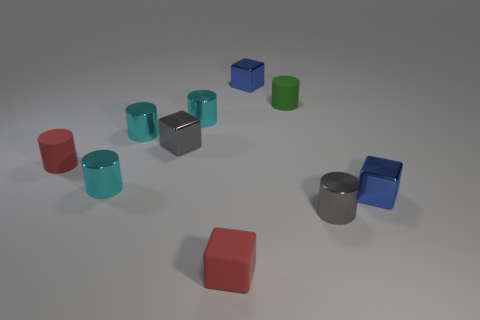Subtract all brown spheres. How many cyan cylinders are left? 3 Subtract all green cylinders. How many cylinders are left? 5 Subtract 1 blocks. How many blocks are left? 3 Subtract all red cylinders. How many cylinders are left? 5 Subtract all yellow blocks. Subtract all brown cylinders. How many blocks are left? 4 Subtract all cubes. How many objects are left? 6 Subtract 2 blue blocks. How many objects are left? 8 Subtract all rubber objects. Subtract all tiny gray cubes. How many objects are left? 6 Add 3 tiny metallic cylinders. How many tiny metallic cylinders are left? 7 Add 8 small gray metal cylinders. How many small gray metal cylinders exist? 9 